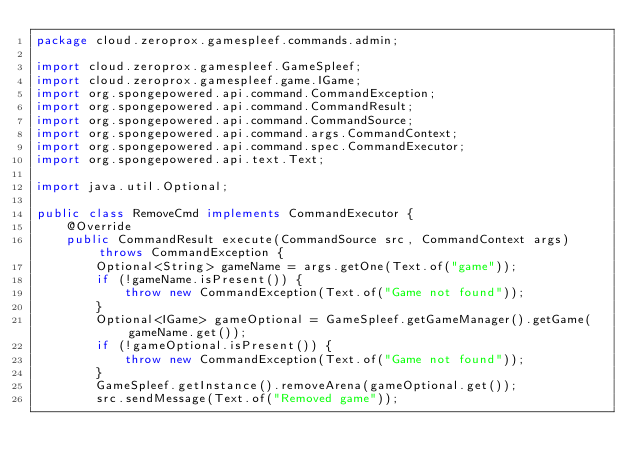Convert code to text. <code><loc_0><loc_0><loc_500><loc_500><_Java_>package cloud.zeroprox.gamespleef.commands.admin;

import cloud.zeroprox.gamespleef.GameSpleef;
import cloud.zeroprox.gamespleef.game.IGame;
import org.spongepowered.api.command.CommandException;
import org.spongepowered.api.command.CommandResult;
import org.spongepowered.api.command.CommandSource;
import org.spongepowered.api.command.args.CommandContext;
import org.spongepowered.api.command.spec.CommandExecutor;
import org.spongepowered.api.text.Text;

import java.util.Optional;

public class RemoveCmd implements CommandExecutor {
    @Override
    public CommandResult execute(CommandSource src, CommandContext args) throws CommandException {
        Optional<String> gameName = args.getOne(Text.of("game"));
        if (!gameName.isPresent()) {
            throw new CommandException(Text.of("Game not found"));
        }
        Optional<IGame> gameOptional = GameSpleef.getGameManager().getGame(gameName.get());
        if (!gameOptional.isPresent()) {
            throw new CommandException(Text.of("Game not found"));
        }
        GameSpleef.getInstance().removeArena(gameOptional.get());
        src.sendMessage(Text.of("Removed game"));</code> 